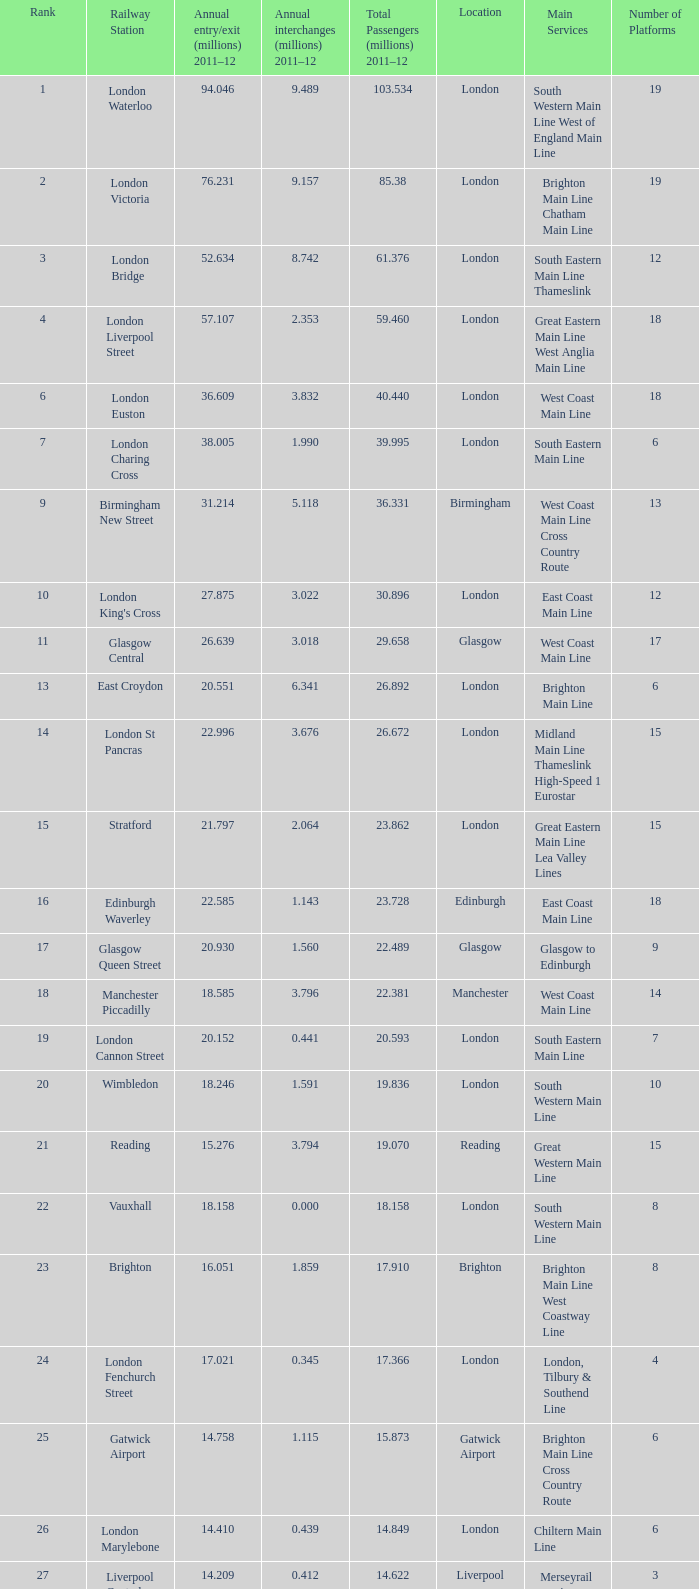Which location has 103.534 million passengers in 2011-12?  London. 